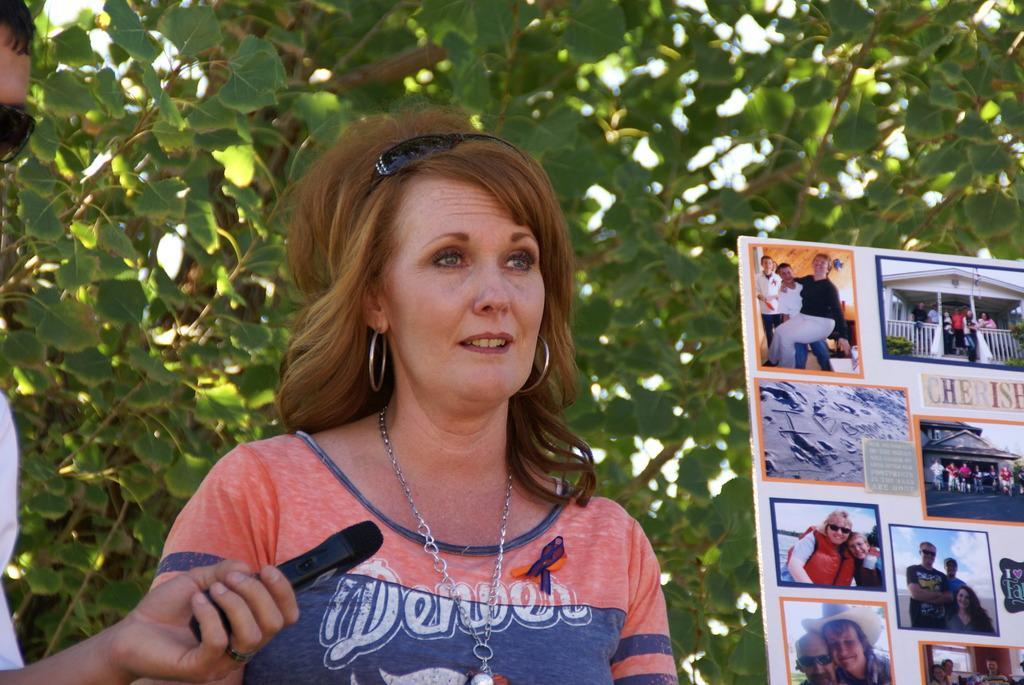How would you summarize this image in a sentence or two? This picture is clicked outside. On the left there is a person holding a black color object and standing. In the center there is a woman wearing t-shirt and standing. On the right corner we can see a poster on which we can see the pictures of some persons and the pictures of the houses. In the background we can see the tree. 